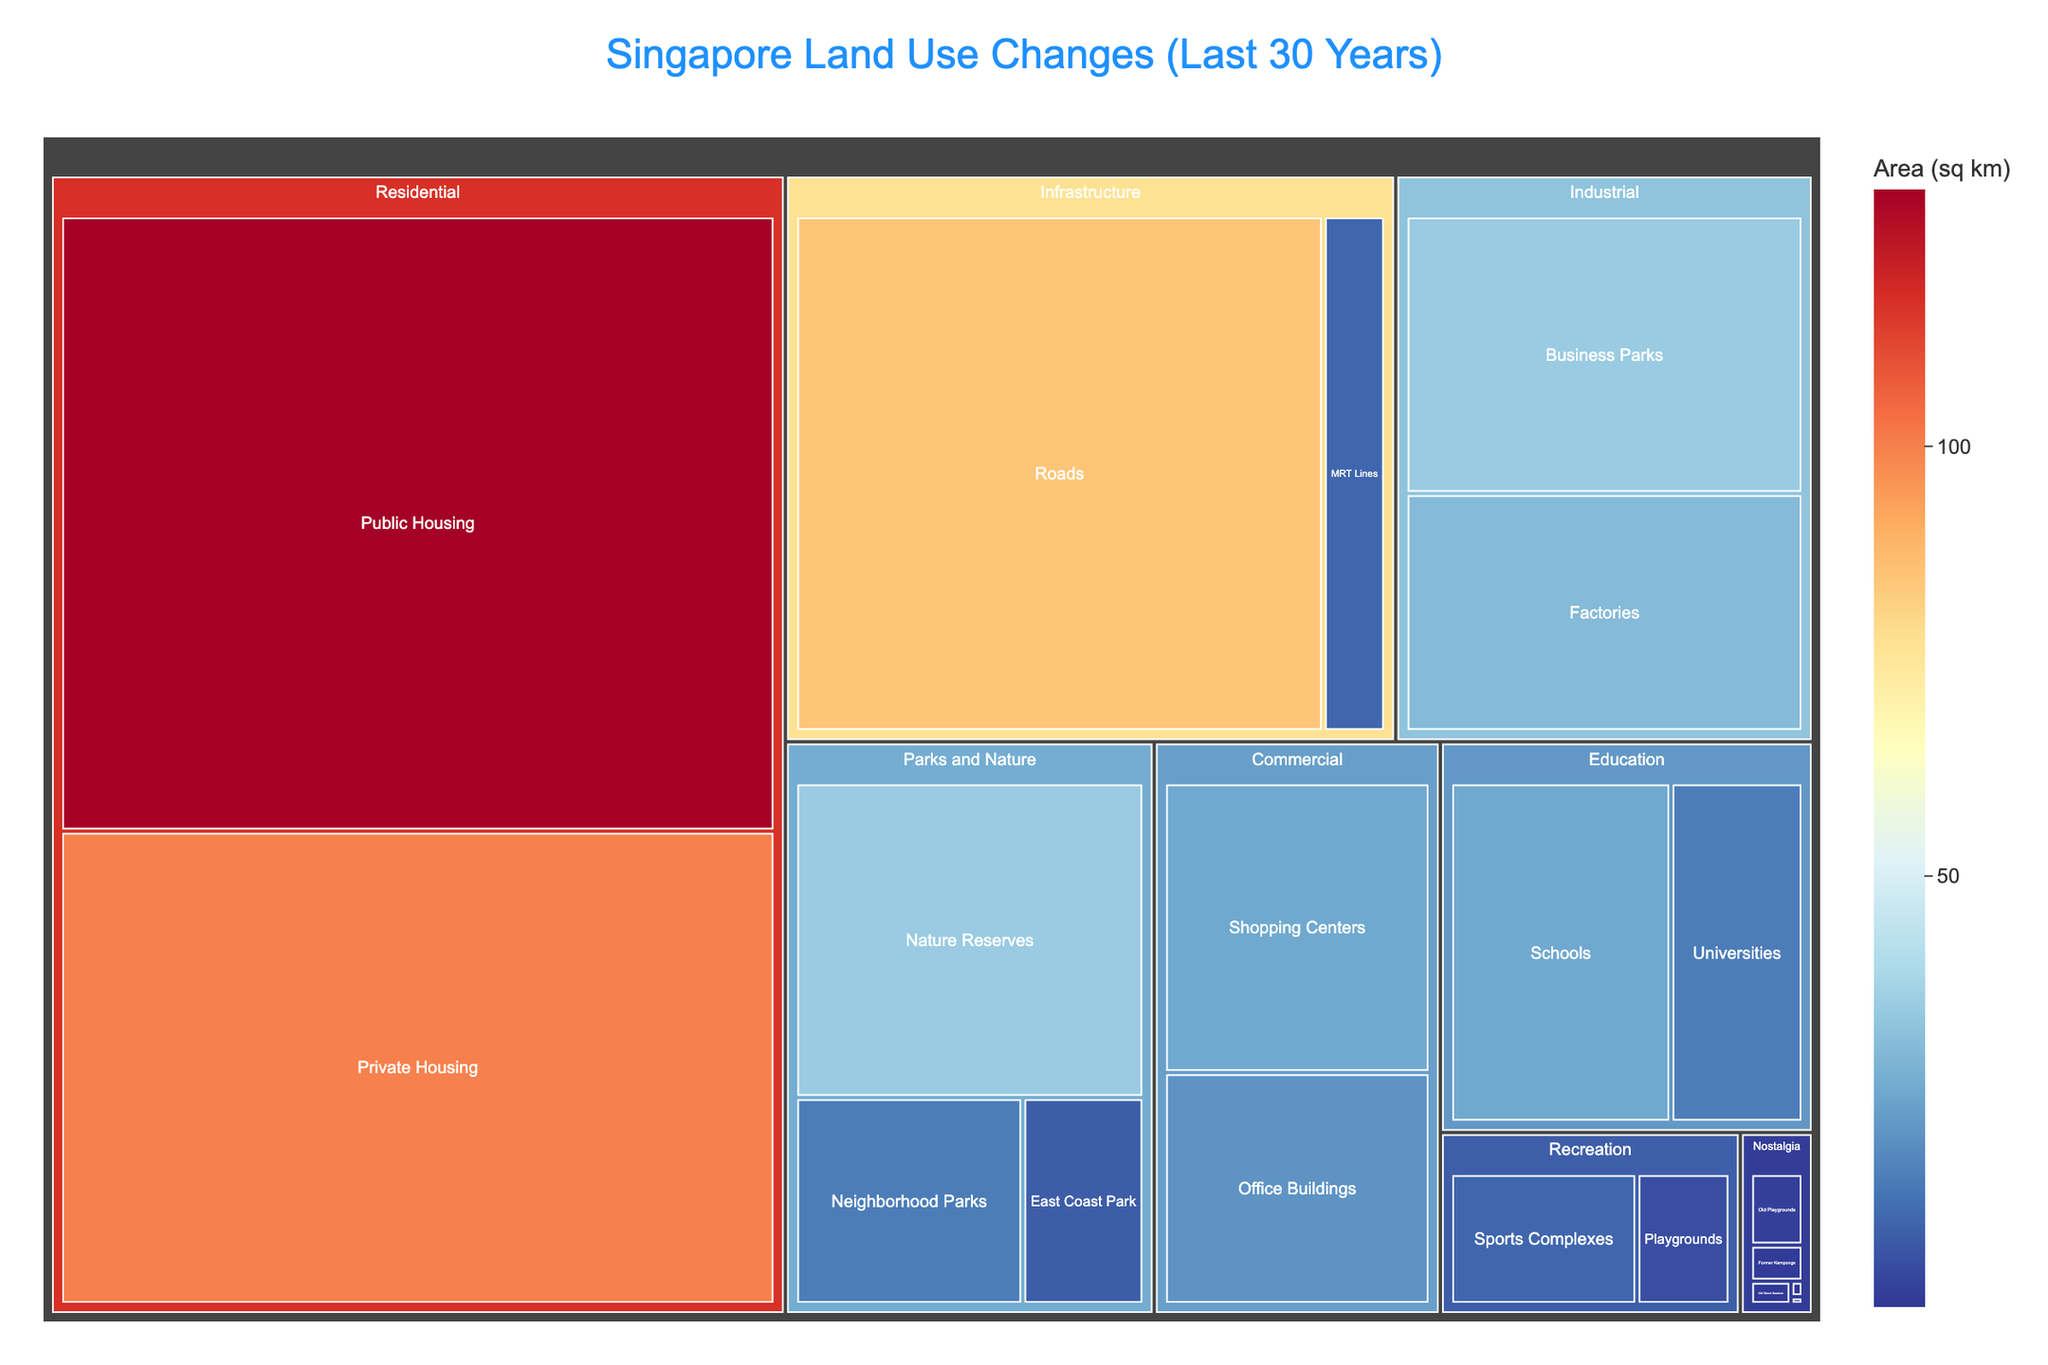what's the title of the treemap? The title is large and centered at the top of the figure. It reads "Singapore Land Use Changes (Last 30 Years)".
Answer: Singapore Land Use Changes (Last 30 Years) which category has the largest area? The treemap shows that the category with the largest area has the most sizeable segment. Residential stands out as the largest.
Answer: Residential how much area is allocated to Industrial purposes? Locate the 'Industrial' category and sum up the area figures for its subcategories (Business Parks and Factories). This results in 35 + 30 = 65 sq km.
Answer: 65 sq km which nostalgia subcategory has the smallest area? Among the 'Nostalgia' subcategories, Sungei Road Flea Market and Dragon Playground are the smallest, with Sungei Road Flea Market being smaller at 0.1 sq km.
Answer: Sungei Road Flea Market how does the area of public housing compare to private housing? Both subcategories are within the Residential category. Public Housing has an area of 130 sq km, which is larger compared to Private Housing with 100 sq km.
Answer: Public Housing is larger what is the combined area of nature reserves and neighborhood parks? Within the 'Parks and Nature' category, sum the areas of 'Nature Reserves' and 'Neighborhood Parks': 35 + 15 = 50 sq km.
Answer: 50 sq km which category does East Coast Park belong to and what’s its area? East Coast Park falls under the 'Parks and Nature' category, and its area is marked as 8 sq km in the treemap.
Answer: Parks and Nature, 8 sq km how many nostalgia subcategories are there in total? Each subcategory under 'Nostalgia' is counted. There are 5 subcategories: Old Playgrounds, Former Kampongs, Old Street Hawkers, Sungei Road Flea Market, and Dragon Playground.
Answer: 5 subcategories what's the area for the combined infrastructure category? Add the areas of the subcategories within 'Infrastructure,' which are Roads (85 sq km) and MRT Lines (10 sq km): 85 + 10 = 95 sq km.
Answer: 95 sq km how does the area of schools compare to that of universities? Both fall under the 'Education' category. Schools cover 25 sq km while Universities cover 15 sq km. Schools have a larger area.
Answer: Schools are larger 